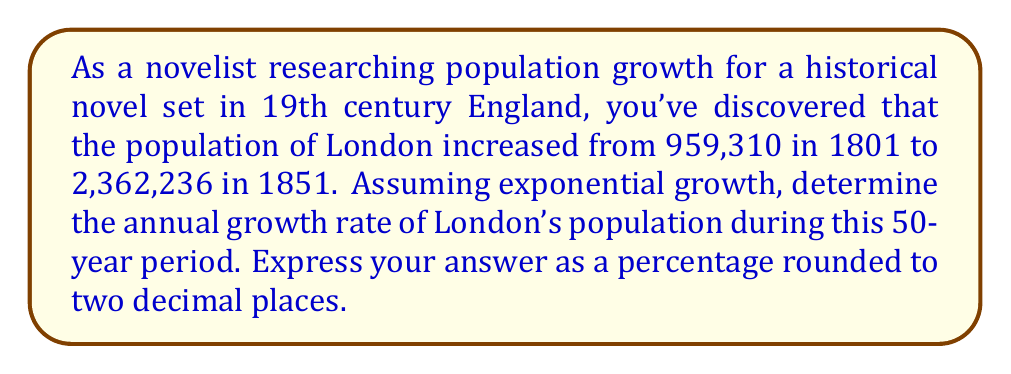Teach me how to tackle this problem. To solve this problem, we'll use the exponential growth formula:

$$A = P(1 + r)^t$$

Where:
$A$ = Final amount (population in 1851)
$P$ = Initial amount (population in 1801)
$r$ = Annual growth rate (what we're solving for)
$t$ = Time period in years

Given:
$A = 2,362,236$
$P = 959,310$
$t = 50$ years

Step 1: Substitute the known values into the formula:
$$2,362,236 = 959,310(1 + r)^{50}$$

Step 2: Divide both sides by 959,310:
$$\frac{2,362,236}{959,310} = (1 + r)^{50}$$

Step 3: Simplify:
$$2.4623 = (1 + r)^{50}$$

Step 4: Take the 50th root of both sides:
$$\sqrt[50]{2.4623} = 1 + r$$

Step 5: Subtract 1 from both sides:
$$\sqrt[50]{2.4623} - 1 = r$$

Step 6: Calculate the value (using a calculator):
$$r \approx 0.018153$$

Step 7: Convert to a percentage by multiplying by 100:
$$r \approx 1.8153\%$$

Step 8: Round to two decimal places:
$$r \approx 1.82\%$$
Answer: The annual population growth rate of London from 1801 to 1851 was approximately 1.82%. 